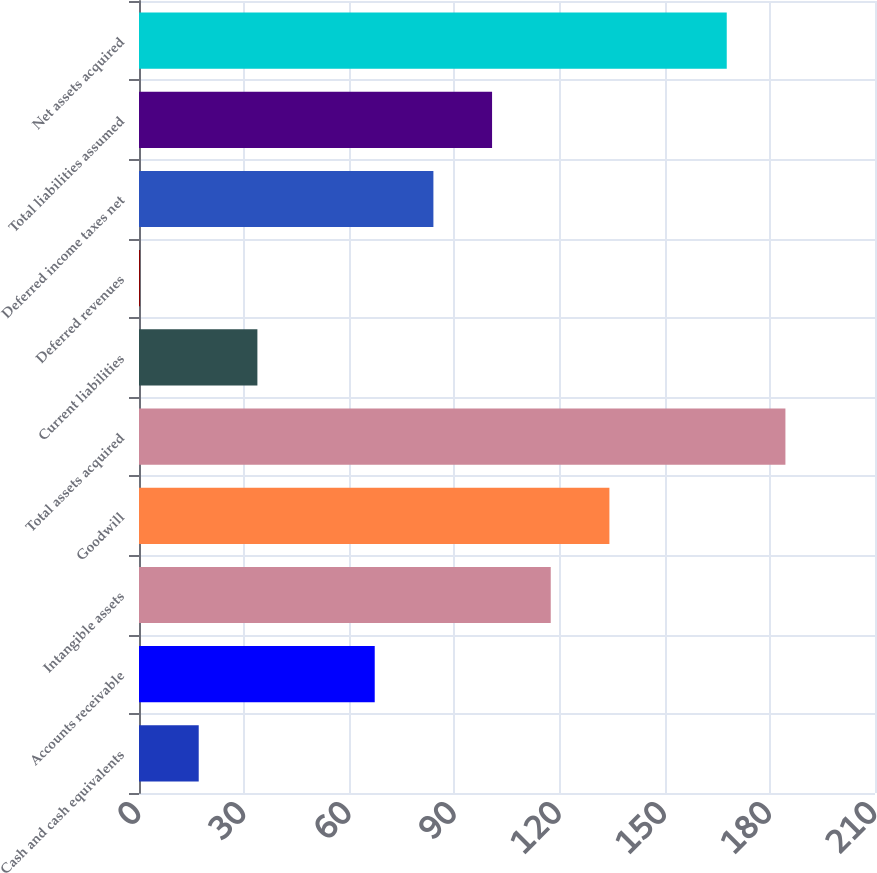Convert chart to OTSL. <chart><loc_0><loc_0><loc_500><loc_500><bar_chart><fcel>Cash and cash equivalents<fcel>Accounts receivable<fcel>Intangible assets<fcel>Goodwill<fcel>Total assets acquired<fcel>Current liabilities<fcel>Deferred revenues<fcel>Deferred income taxes net<fcel>Total liabilities assumed<fcel>Net assets acquired<nl><fcel>17.04<fcel>67.26<fcel>117.48<fcel>134.22<fcel>184.44<fcel>33.78<fcel>0.3<fcel>84<fcel>100.74<fcel>167.7<nl></chart> 